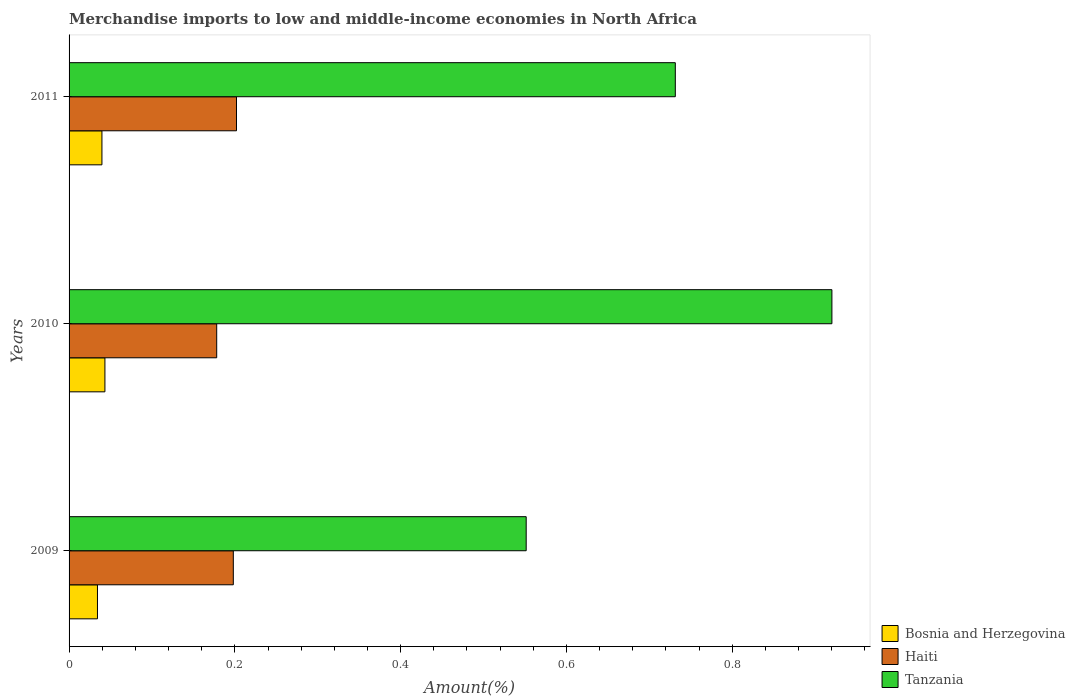How many groups of bars are there?
Your response must be concise. 3. In how many cases, is the number of bars for a given year not equal to the number of legend labels?
Your answer should be very brief. 0. What is the percentage of amount earned from merchandise imports in Haiti in 2009?
Your answer should be compact. 0.2. Across all years, what is the maximum percentage of amount earned from merchandise imports in Bosnia and Herzegovina?
Make the answer very short. 0.04. Across all years, what is the minimum percentage of amount earned from merchandise imports in Bosnia and Herzegovina?
Offer a very short reply. 0.03. What is the total percentage of amount earned from merchandise imports in Tanzania in the graph?
Your answer should be very brief. 2.2. What is the difference between the percentage of amount earned from merchandise imports in Bosnia and Herzegovina in 2009 and that in 2010?
Your answer should be very brief. -0.01. What is the difference between the percentage of amount earned from merchandise imports in Haiti in 2010 and the percentage of amount earned from merchandise imports in Tanzania in 2009?
Make the answer very short. -0.37. What is the average percentage of amount earned from merchandise imports in Bosnia and Herzegovina per year?
Provide a succinct answer. 0.04. In the year 2009, what is the difference between the percentage of amount earned from merchandise imports in Haiti and percentage of amount earned from merchandise imports in Tanzania?
Make the answer very short. -0.35. What is the ratio of the percentage of amount earned from merchandise imports in Haiti in 2009 to that in 2010?
Offer a terse response. 1.11. What is the difference between the highest and the second highest percentage of amount earned from merchandise imports in Haiti?
Your answer should be compact. 0. What is the difference between the highest and the lowest percentage of amount earned from merchandise imports in Bosnia and Herzegovina?
Give a very brief answer. 0.01. Is the sum of the percentage of amount earned from merchandise imports in Haiti in 2009 and 2011 greater than the maximum percentage of amount earned from merchandise imports in Tanzania across all years?
Your answer should be very brief. No. What does the 2nd bar from the top in 2010 represents?
Offer a terse response. Haiti. What does the 3rd bar from the bottom in 2010 represents?
Your response must be concise. Tanzania. How many bars are there?
Your answer should be very brief. 9. Are all the bars in the graph horizontal?
Offer a terse response. Yes. Does the graph contain grids?
Your answer should be very brief. No. Where does the legend appear in the graph?
Your answer should be very brief. Bottom right. How are the legend labels stacked?
Ensure brevity in your answer.  Vertical. What is the title of the graph?
Give a very brief answer. Merchandise imports to low and middle-income economies in North Africa. Does "Hungary" appear as one of the legend labels in the graph?
Offer a very short reply. No. What is the label or title of the X-axis?
Provide a succinct answer. Amount(%). What is the label or title of the Y-axis?
Your answer should be compact. Years. What is the Amount(%) in Bosnia and Herzegovina in 2009?
Keep it short and to the point. 0.03. What is the Amount(%) in Haiti in 2009?
Ensure brevity in your answer.  0.2. What is the Amount(%) in Tanzania in 2009?
Your response must be concise. 0.55. What is the Amount(%) of Bosnia and Herzegovina in 2010?
Your answer should be compact. 0.04. What is the Amount(%) in Haiti in 2010?
Give a very brief answer. 0.18. What is the Amount(%) of Tanzania in 2010?
Provide a succinct answer. 0.92. What is the Amount(%) in Bosnia and Herzegovina in 2011?
Your answer should be compact. 0.04. What is the Amount(%) in Haiti in 2011?
Your answer should be compact. 0.2. What is the Amount(%) in Tanzania in 2011?
Provide a succinct answer. 0.73. Across all years, what is the maximum Amount(%) in Bosnia and Herzegovina?
Give a very brief answer. 0.04. Across all years, what is the maximum Amount(%) in Haiti?
Keep it short and to the point. 0.2. Across all years, what is the maximum Amount(%) of Tanzania?
Provide a short and direct response. 0.92. Across all years, what is the minimum Amount(%) in Bosnia and Herzegovina?
Keep it short and to the point. 0.03. Across all years, what is the minimum Amount(%) of Haiti?
Ensure brevity in your answer.  0.18. Across all years, what is the minimum Amount(%) of Tanzania?
Your response must be concise. 0.55. What is the total Amount(%) in Bosnia and Herzegovina in the graph?
Ensure brevity in your answer.  0.12. What is the total Amount(%) of Haiti in the graph?
Offer a very short reply. 0.58. What is the total Amount(%) in Tanzania in the graph?
Ensure brevity in your answer.  2.2. What is the difference between the Amount(%) in Bosnia and Herzegovina in 2009 and that in 2010?
Give a very brief answer. -0.01. What is the difference between the Amount(%) in Haiti in 2009 and that in 2010?
Give a very brief answer. 0.02. What is the difference between the Amount(%) in Tanzania in 2009 and that in 2010?
Give a very brief answer. -0.37. What is the difference between the Amount(%) of Bosnia and Herzegovina in 2009 and that in 2011?
Ensure brevity in your answer.  -0.01. What is the difference between the Amount(%) in Haiti in 2009 and that in 2011?
Provide a succinct answer. -0. What is the difference between the Amount(%) of Tanzania in 2009 and that in 2011?
Your response must be concise. -0.18. What is the difference between the Amount(%) in Bosnia and Herzegovina in 2010 and that in 2011?
Offer a terse response. 0. What is the difference between the Amount(%) in Haiti in 2010 and that in 2011?
Ensure brevity in your answer.  -0.02. What is the difference between the Amount(%) of Tanzania in 2010 and that in 2011?
Keep it short and to the point. 0.19. What is the difference between the Amount(%) in Bosnia and Herzegovina in 2009 and the Amount(%) in Haiti in 2010?
Your answer should be very brief. -0.14. What is the difference between the Amount(%) of Bosnia and Herzegovina in 2009 and the Amount(%) of Tanzania in 2010?
Your answer should be compact. -0.89. What is the difference between the Amount(%) of Haiti in 2009 and the Amount(%) of Tanzania in 2010?
Your response must be concise. -0.72. What is the difference between the Amount(%) in Bosnia and Herzegovina in 2009 and the Amount(%) in Haiti in 2011?
Offer a very short reply. -0.17. What is the difference between the Amount(%) of Bosnia and Herzegovina in 2009 and the Amount(%) of Tanzania in 2011?
Your answer should be compact. -0.7. What is the difference between the Amount(%) of Haiti in 2009 and the Amount(%) of Tanzania in 2011?
Ensure brevity in your answer.  -0.53. What is the difference between the Amount(%) of Bosnia and Herzegovina in 2010 and the Amount(%) of Haiti in 2011?
Your response must be concise. -0.16. What is the difference between the Amount(%) of Bosnia and Herzegovina in 2010 and the Amount(%) of Tanzania in 2011?
Ensure brevity in your answer.  -0.69. What is the difference between the Amount(%) of Haiti in 2010 and the Amount(%) of Tanzania in 2011?
Provide a succinct answer. -0.55. What is the average Amount(%) of Bosnia and Herzegovina per year?
Your response must be concise. 0.04. What is the average Amount(%) of Haiti per year?
Your response must be concise. 0.19. What is the average Amount(%) of Tanzania per year?
Offer a terse response. 0.73. In the year 2009, what is the difference between the Amount(%) in Bosnia and Herzegovina and Amount(%) in Haiti?
Keep it short and to the point. -0.16. In the year 2009, what is the difference between the Amount(%) in Bosnia and Herzegovina and Amount(%) in Tanzania?
Offer a very short reply. -0.52. In the year 2009, what is the difference between the Amount(%) of Haiti and Amount(%) of Tanzania?
Make the answer very short. -0.35. In the year 2010, what is the difference between the Amount(%) in Bosnia and Herzegovina and Amount(%) in Haiti?
Keep it short and to the point. -0.13. In the year 2010, what is the difference between the Amount(%) in Bosnia and Herzegovina and Amount(%) in Tanzania?
Provide a succinct answer. -0.88. In the year 2010, what is the difference between the Amount(%) in Haiti and Amount(%) in Tanzania?
Offer a terse response. -0.74. In the year 2011, what is the difference between the Amount(%) of Bosnia and Herzegovina and Amount(%) of Haiti?
Your answer should be compact. -0.16. In the year 2011, what is the difference between the Amount(%) in Bosnia and Herzegovina and Amount(%) in Tanzania?
Your response must be concise. -0.69. In the year 2011, what is the difference between the Amount(%) of Haiti and Amount(%) of Tanzania?
Your response must be concise. -0.53. What is the ratio of the Amount(%) of Bosnia and Herzegovina in 2009 to that in 2010?
Your answer should be very brief. 0.79. What is the ratio of the Amount(%) in Haiti in 2009 to that in 2010?
Provide a short and direct response. 1.11. What is the ratio of the Amount(%) in Tanzania in 2009 to that in 2010?
Make the answer very short. 0.6. What is the ratio of the Amount(%) of Bosnia and Herzegovina in 2009 to that in 2011?
Ensure brevity in your answer.  0.86. What is the ratio of the Amount(%) in Haiti in 2009 to that in 2011?
Give a very brief answer. 0.98. What is the ratio of the Amount(%) of Tanzania in 2009 to that in 2011?
Provide a short and direct response. 0.75. What is the ratio of the Amount(%) in Bosnia and Herzegovina in 2010 to that in 2011?
Keep it short and to the point. 1.09. What is the ratio of the Amount(%) in Haiti in 2010 to that in 2011?
Offer a terse response. 0.88. What is the ratio of the Amount(%) in Tanzania in 2010 to that in 2011?
Give a very brief answer. 1.26. What is the difference between the highest and the second highest Amount(%) in Bosnia and Herzegovina?
Make the answer very short. 0. What is the difference between the highest and the second highest Amount(%) of Haiti?
Give a very brief answer. 0. What is the difference between the highest and the second highest Amount(%) in Tanzania?
Offer a very short reply. 0.19. What is the difference between the highest and the lowest Amount(%) of Bosnia and Herzegovina?
Your answer should be very brief. 0.01. What is the difference between the highest and the lowest Amount(%) in Haiti?
Provide a short and direct response. 0.02. What is the difference between the highest and the lowest Amount(%) of Tanzania?
Ensure brevity in your answer.  0.37. 